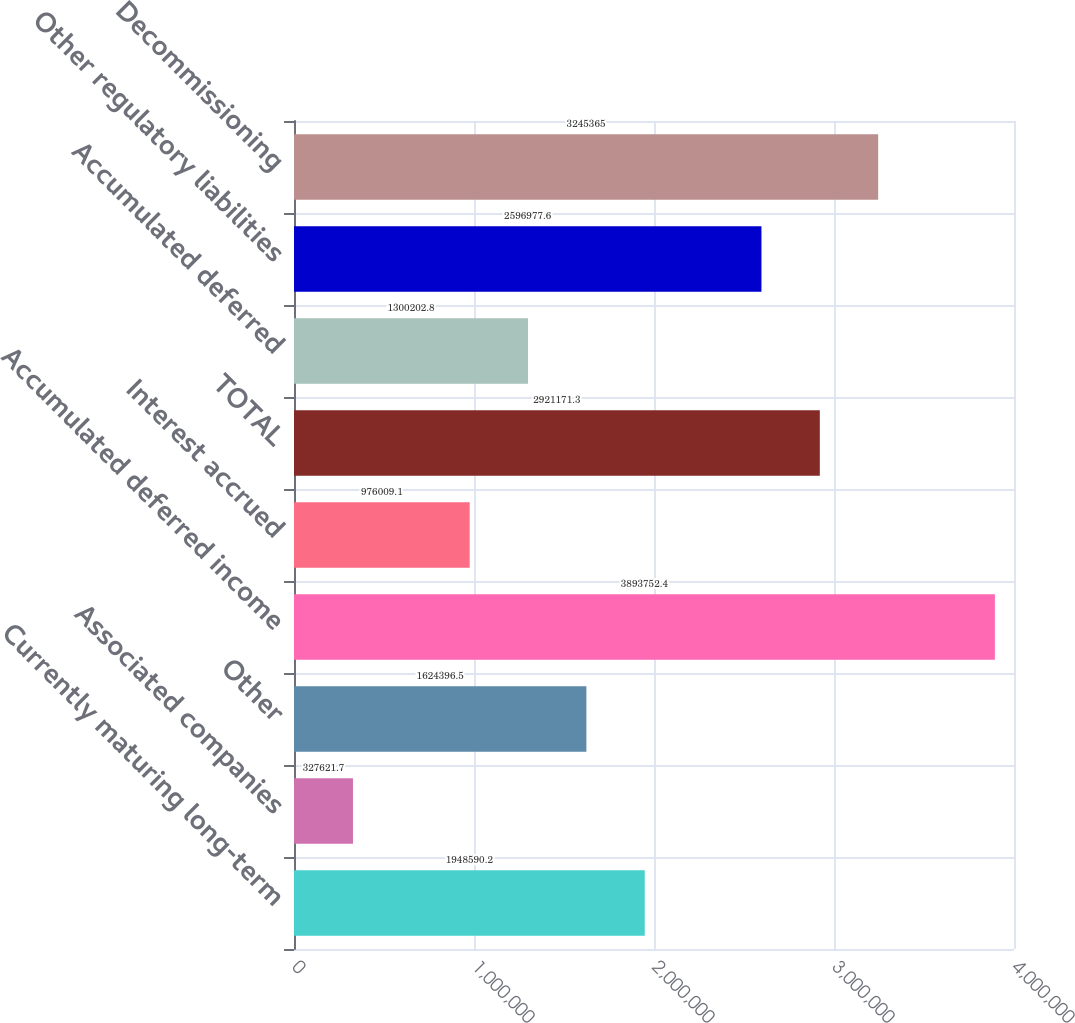Convert chart to OTSL. <chart><loc_0><loc_0><loc_500><loc_500><bar_chart><fcel>Currently maturing long-term<fcel>Associated companies<fcel>Other<fcel>Accumulated deferred income<fcel>Interest accrued<fcel>TOTAL<fcel>Accumulated deferred<fcel>Other regulatory liabilities<fcel>Decommissioning<nl><fcel>1.94859e+06<fcel>327622<fcel>1.6244e+06<fcel>3.89375e+06<fcel>976009<fcel>2.92117e+06<fcel>1.3002e+06<fcel>2.59698e+06<fcel>3.24536e+06<nl></chart> 